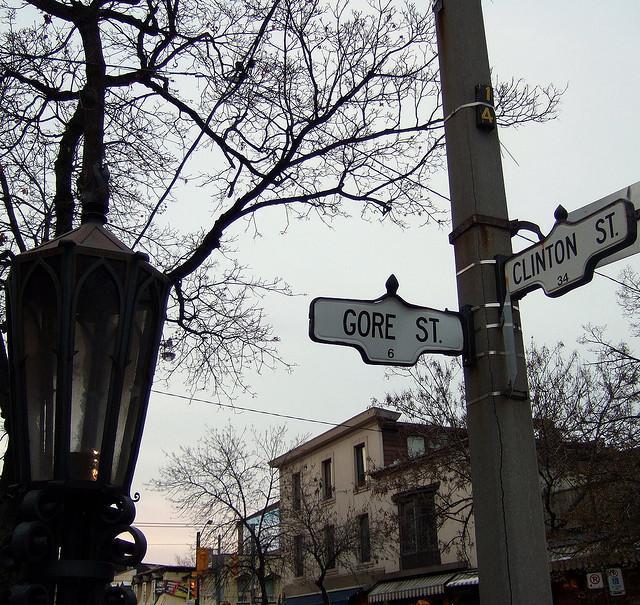How many of the cows in this picture are chocolate brown?
Give a very brief answer. 0. 